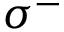<formula> <loc_0><loc_0><loc_500><loc_500>\sigma ^ { - }</formula> 